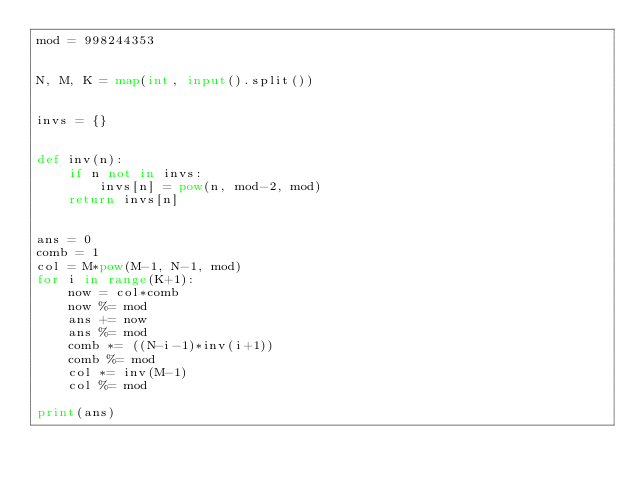Convert code to text. <code><loc_0><loc_0><loc_500><loc_500><_Python_>mod = 998244353


N, M, K = map(int, input().split())


invs = {}


def inv(n):
    if n not in invs:
        invs[n] = pow(n, mod-2, mod)
    return invs[n]


ans = 0
comb = 1
col = M*pow(M-1, N-1, mod)
for i in range(K+1):
    now = col*comb
    now %= mod
    ans += now
    ans %= mod
    comb *= ((N-i-1)*inv(i+1))
    comb %= mod
    col *= inv(M-1)
    col %= mod

print(ans)
</code> 